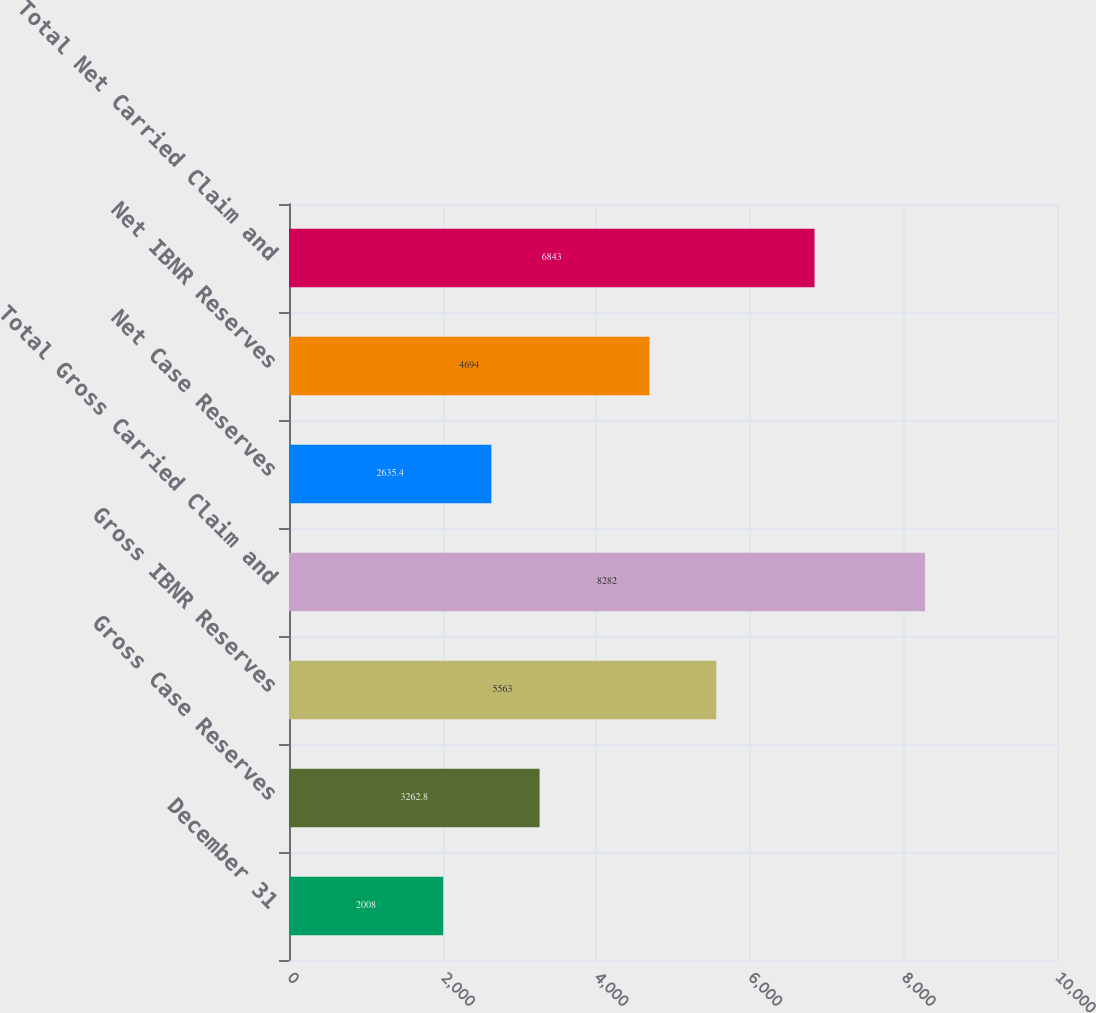Convert chart to OTSL. <chart><loc_0><loc_0><loc_500><loc_500><bar_chart><fcel>December 31<fcel>Gross Case Reserves<fcel>Gross IBNR Reserves<fcel>Total Gross Carried Claim and<fcel>Net Case Reserves<fcel>Net IBNR Reserves<fcel>Total Net Carried Claim and<nl><fcel>2008<fcel>3262.8<fcel>5563<fcel>8282<fcel>2635.4<fcel>4694<fcel>6843<nl></chart> 